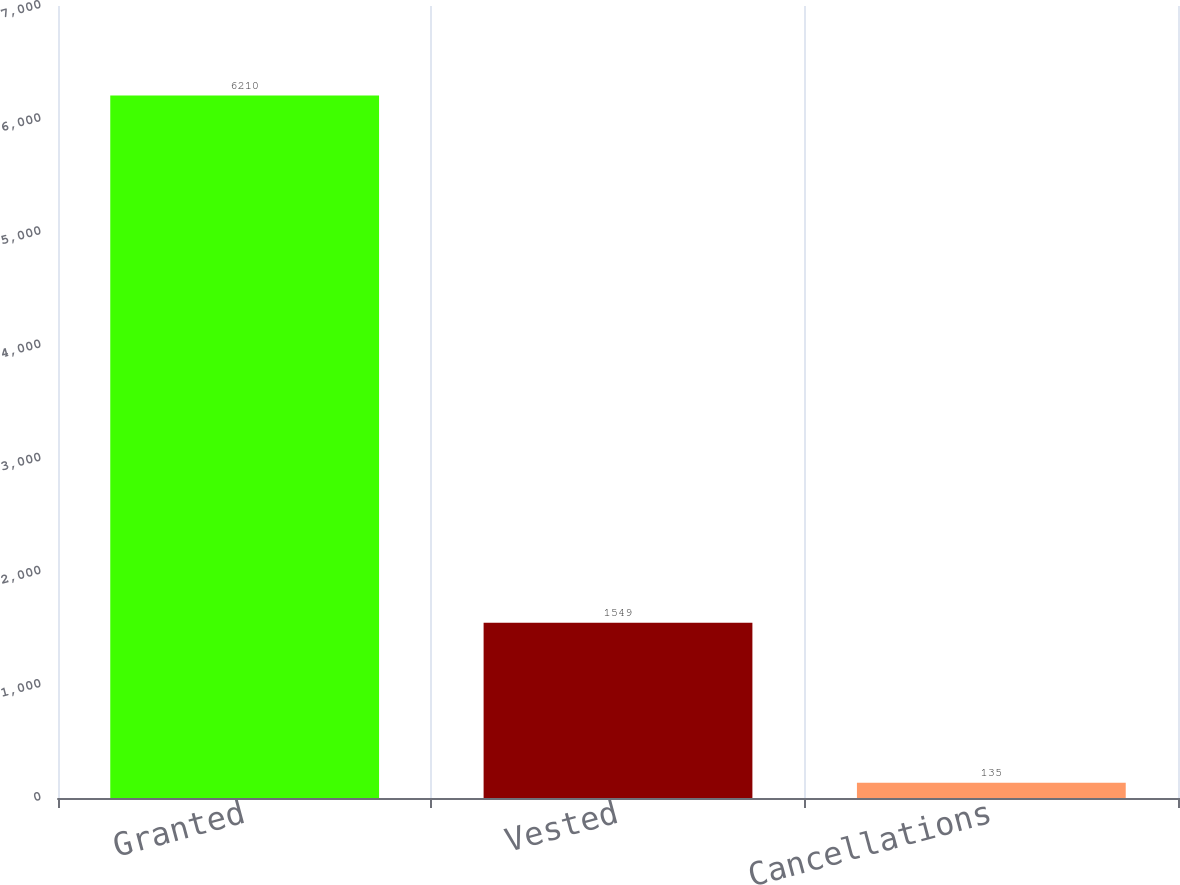Convert chart. <chart><loc_0><loc_0><loc_500><loc_500><bar_chart><fcel>Granted<fcel>Vested<fcel>Cancellations<nl><fcel>6210<fcel>1549<fcel>135<nl></chart> 